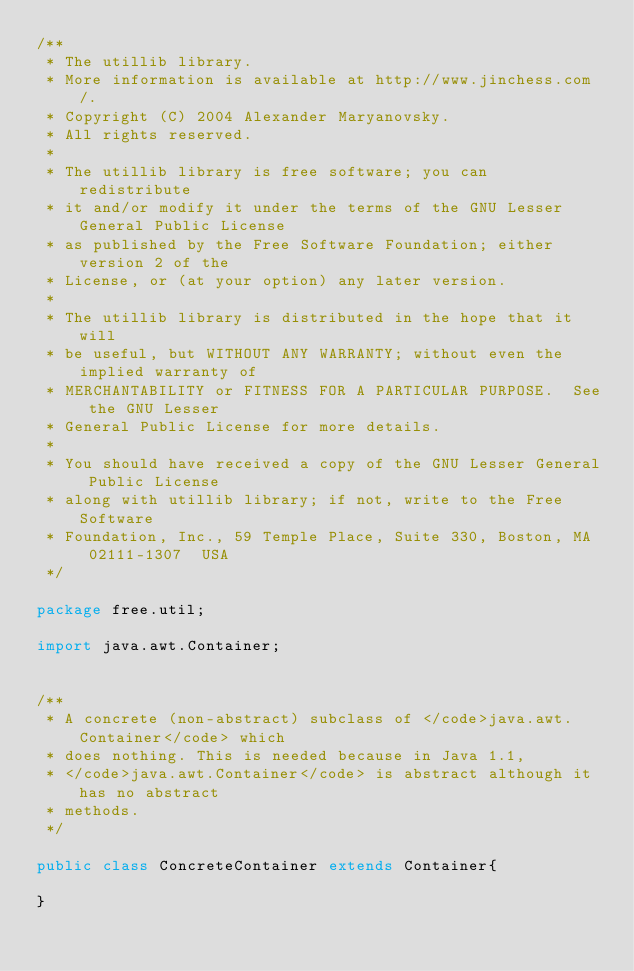<code> <loc_0><loc_0><loc_500><loc_500><_Java_>/**
 * The utillib library.
 * More information is available at http://www.jinchess.com/.
 * Copyright (C) 2004 Alexander Maryanovsky.
 * All rights reserved.
 *
 * The utillib library is free software; you can redistribute
 * it and/or modify it under the terms of the GNU Lesser General Public License
 * as published by the Free Software Foundation; either version 2 of the
 * License, or (at your option) any later version.
 *
 * The utillib library is distributed in the hope that it will
 * be useful, but WITHOUT ANY WARRANTY; without even the implied warranty of
 * MERCHANTABILITY or FITNESS FOR A PARTICULAR PURPOSE.  See the GNU Lesser
 * General Public License for more details.
 *
 * You should have received a copy of the GNU Lesser General Public License
 * along with utillib library; if not, write to the Free Software
 * Foundation, Inc., 59 Temple Place, Suite 330, Boston, MA  02111-1307  USA
 */

package free.util;

import java.awt.Container;


/**
 * A concrete (non-abstract) subclass of </code>java.awt.Container</code> which
 * does nothing. This is needed because in Java 1.1,
 * </code>java.awt.Container</code> is abstract although it has no abstract
 * methods.
 */
 
public class ConcreteContainer extends Container{
   
}
</code> 